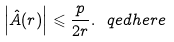<formula> <loc_0><loc_0><loc_500><loc_500>\left | \hat { A } ( r ) \right | \leqslant \frac { p } { 2 r } . \ q e d h e r e</formula> 